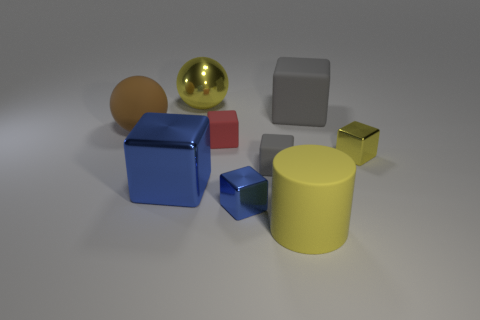There is a rubber cylinder; is it the same color as the small object that is to the right of the large matte cylinder?
Your answer should be compact. Yes. Are there any things of the same color as the large cylinder?
Offer a very short reply. Yes. What number of large matte things are the same shape as the small yellow thing?
Provide a succinct answer. 1. There is a big object that is right of the red rubber cube and in front of the big brown sphere; what material is it?
Offer a very short reply. Rubber. Does the small blue block have the same material as the yellow ball?
Give a very brief answer. Yes. How many gray matte blocks are there?
Provide a succinct answer. 2. The tiny cube that is in front of the small matte object that is on the right side of the tiny matte block that is to the left of the small blue thing is what color?
Provide a succinct answer. Blue. Is the matte cylinder the same color as the big metal ball?
Provide a succinct answer. Yes. What number of small cubes are on the left side of the yellow block and behind the small gray rubber cube?
Provide a short and direct response. 1. How many matte things are either balls or big gray blocks?
Provide a short and direct response. 2. 